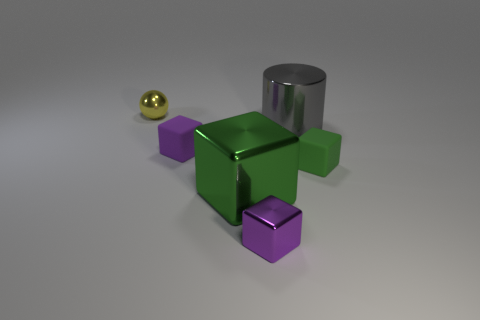Subtract all tiny blocks. How many blocks are left? 1 Add 4 small gray cubes. How many objects exist? 10 Subtract all purple cubes. How many cubes are left? 2 Subtract all cyan cylinders. How many green blocks are left? 2 Subtract all balls. How many objects are left? 5 Subtract 0 gray blocks. How many objects are left? 6 Subtract 2 blocks. How many blocks are left? 2 Subtract all green cylinders. Subtract all yellow spheres. How many cylinders are left? 1 Subtract all green blocks. Subtract all tiny metallic blocks. How many objects are left? 3 Add 1 purple metallic blocks. How many purple metallic blocks are left? 2 